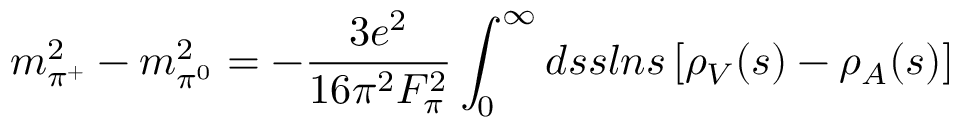<formula> <loc_0><loc_0><loc_500><loc_500>m _ { \pi ^ { + } } ^ { 2 } - m _ { \pi ^ { 0 } } ^ { 2 } = - { \frac { 3 e ^ { 2 } } { 1 6 \pi ^ { 2 } F _ { \pi } ^ { 2 } } } \int _ { 0 } ^ { \infty } d s s \ln s \left [ \rho _ { V } ( s ) - \rho _ { A } ( s ) \right ]</formula> 